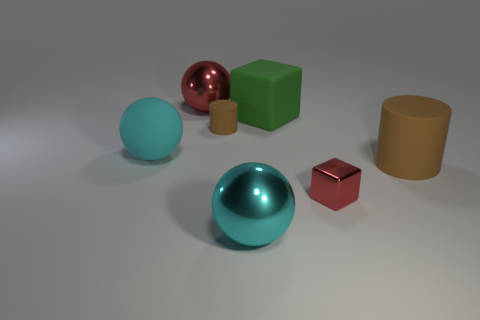How does the reflective quality of the sphere differ from the other objects? The sphere has a highly reflective, shiny surface that seems metallic, contrasting with the matte surfaces of the other objects which scatter light more diffusely. 